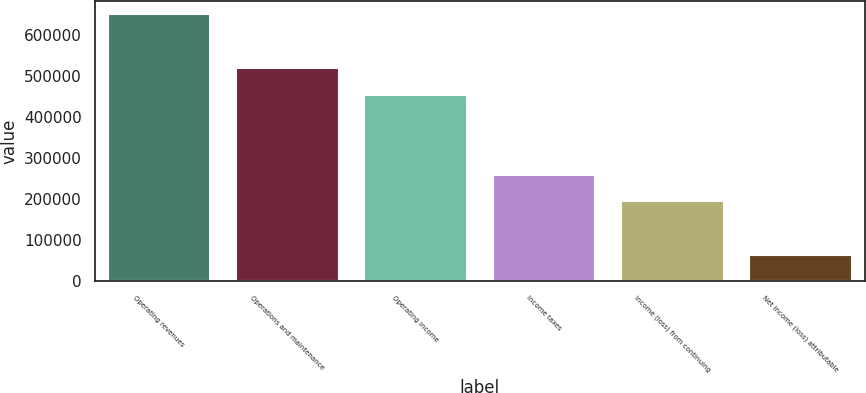Convert chart to OTSL. <chart><loc_0><loc_0><loc_500><loc_500><bar_chart><fcel>Operating revenues<fcel>Operations and maintenance<fcel>Operating income<fcel>Income taxes<fcel>Income (loss) from continuing<fcel>Net income (loss) attributable<nl><fcel>648847<fcel>519078<fcel>454193<fcel>259539<fcel>194654<fcel>64884.8<nl></chart> 